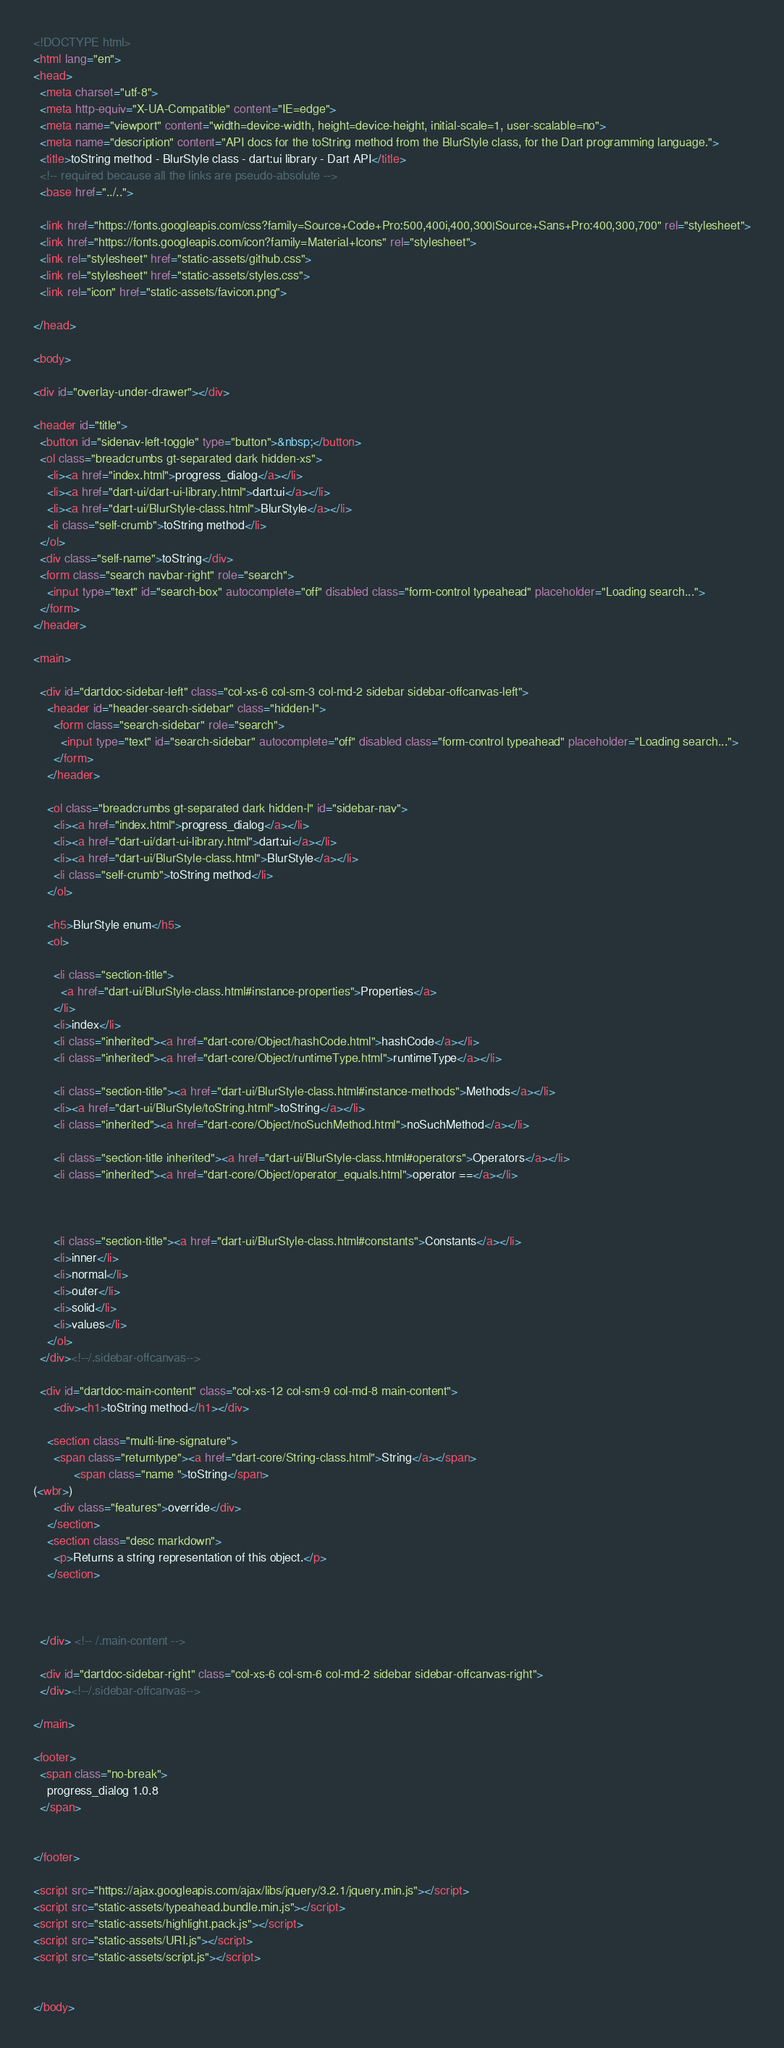Convert code to text. <code><loc_0><loc_0><loc_500><loc_500><_HTML_><!DOCTYPE html>
<html lang="en">
<head>
  <meta charset="utf-8">
  <meta http-equiv="X-UA-Compatible" content="IE=edge">
  <meta name="viewport" content="width=device-width, height=device-height, initial-scale=1, user-scalable=no">
  <meta name="description" content="API docs for the toString method from the BlurStyle class, for the Dart programming language.">
  <title>toString method - BlurStyle class - dart:ui library - Dart API</title>
  <!-- required because all the links are pseudo-absolute -->
  <base href="../..">

  <link href="https://fonts.googleapis.com/css?family=Source+Code+Pro:500,400i,400,300|Source+Sans+Pro:400,300,700" rel="stylesheet">
  <link href="https://fonts.googleapis.com/icon?family=Material+Icons" rel="stylesheet">
  <link rel="stylesheet" href="static-assets/github.css">
  <link rel="stylesheet" href="static-assets/styles.css">
  <link rel="icon" href="static-assets/favicon.png">
  
</head>

<body>

<div id="overlay-under-drawer"></div>

<header id="title">
  <button id="sidenav-left-toggle" type="button">&nbsp;</button>
  <ol class="breadcrumbs gt-separated dark hidden-xs">
    <li><a href="index.html">progress_dialog</a></li>
    <li><a href="dart-ui/dart-ui-library.html">dart:ui</a></li>
    <li><a href="dart-ui/BlurStyle-class.html">BlurStyle</a></li>
    <li class="self-crumb">toString method</li>
  </ol>
  <div class="self-name">toString</div>
  <form class="search navbar-right" role="search">
    <input type="text" id="search-box" autocomplete="off" disabled class="form-control typeahead" placeholder="Loading search...">
  </form>
</header>

<main>

  <div id="dartdoc-sidebar-left" class="col-xs-6 col-sm-3 col-md-2 sidebar sidebar-offcanvas-left">
    <header id="header-search-sidebar" class="hidden-l">
      <form class="search-sidebar" role="search">
        <input type="text" id="search-sidebar" autocomplete="off" disabled class="form-control typeahead" placeholder="Loading search...">
      </form>
    </header>
    
    <ol class="breadcrumbs gt-separated dark hidden-l" id="sidebar-nav">
      <li><a href="index.html">progress_dialog</a></li>
      <li><a href="dart-ui/dart-ui-library.html">dart:ui</a></li>
      <li><a href="dart-ui/BlurStyle-class.html">BlurStyle</a></li>
      <li class="self-crumb">toString method</li>
    </ol>
    
    <h5>BlurStyle enum</h5>
    <ol>
    
      <li class="section-title">
        <a href="dart-ui/BlurStyle-class.html#instance-properties">Properties</a>
      </li>
      <li>index</li>
      <li class="inherited"><a href="dart-core/Object/hashCode.html">hashCode</a></li>
      <li class="inherited"><a href="dart-core/Object/runtimeType.html">runtimeType</a></li>
    
      <li class="section-title"><a href="dart-ui/BlurStyle-class.html#instance-methods">Methods</a></li>
      <li><a href="dart-ui/BlurStyle/toString.html">toString</a></li>
      <li class="inherited"><a href="dart-core/Object/noSuchMethod.html">noSuchMethod</a></li>
    
      <li class="section-title inherited"><a href="dart-ui/BlurStyle-class.html#operators">Operators</a></li>
      <li class="inherited"><a href="dart-core/Object/operator_equals.html">operator ==</a></li>
    
    
    
      <li class="section-title"><a href="dart-ui/BlurStyle-class.html#constants">Constants</a></li>
      <li>inner</li>
      <li>normal</li>
      <li>outer</li>
      <li>solid</li>
      <li>values</li>
    </ol>
  </div><!--/.sidebar-offcanvas-->

  <div id="dartdoc-main-content" class="col-xs-12 col-sm-9 col-md-8 main-content">
      <div><h1>toString method</h1></div>

    <section class="multi-line-signature">
      <span class="returntype"><a href="dart-core/String-class.html">String</a></span>
            <span class="name ">toString</span>
(<wbr>)
      <div class="features">override</div>
    </section>
    <section class="desc markdown">
      <p>Returns a string representation of this object.</p>
    </section>
    
    

  </div> <!-- /.main-content -->

  <div id="dartdoc-sidebar-right" class="col-xs-6 col-sm-6 col-md-2 sidebar sidebar-offcanvas-right">
  </div><!--/.sidebar-offcanvas-->

</main>

<footer>
  <span class="no-break">
    progress_dialog 1.0.8
  </span>

  
</footer>

<script src="https://ajax.googleapis.com/ajax/libs/jquery/3.2.1/jquery.min.js"></script>
<script src="static-assets/typeahead.bundle.min.js"></script>
<script src="static-assets/highlight.pack.js"></script>
<script src="static-assets/URI.js"></script>
<script src="static-assets/script.js"></script>


</body>
</code> 